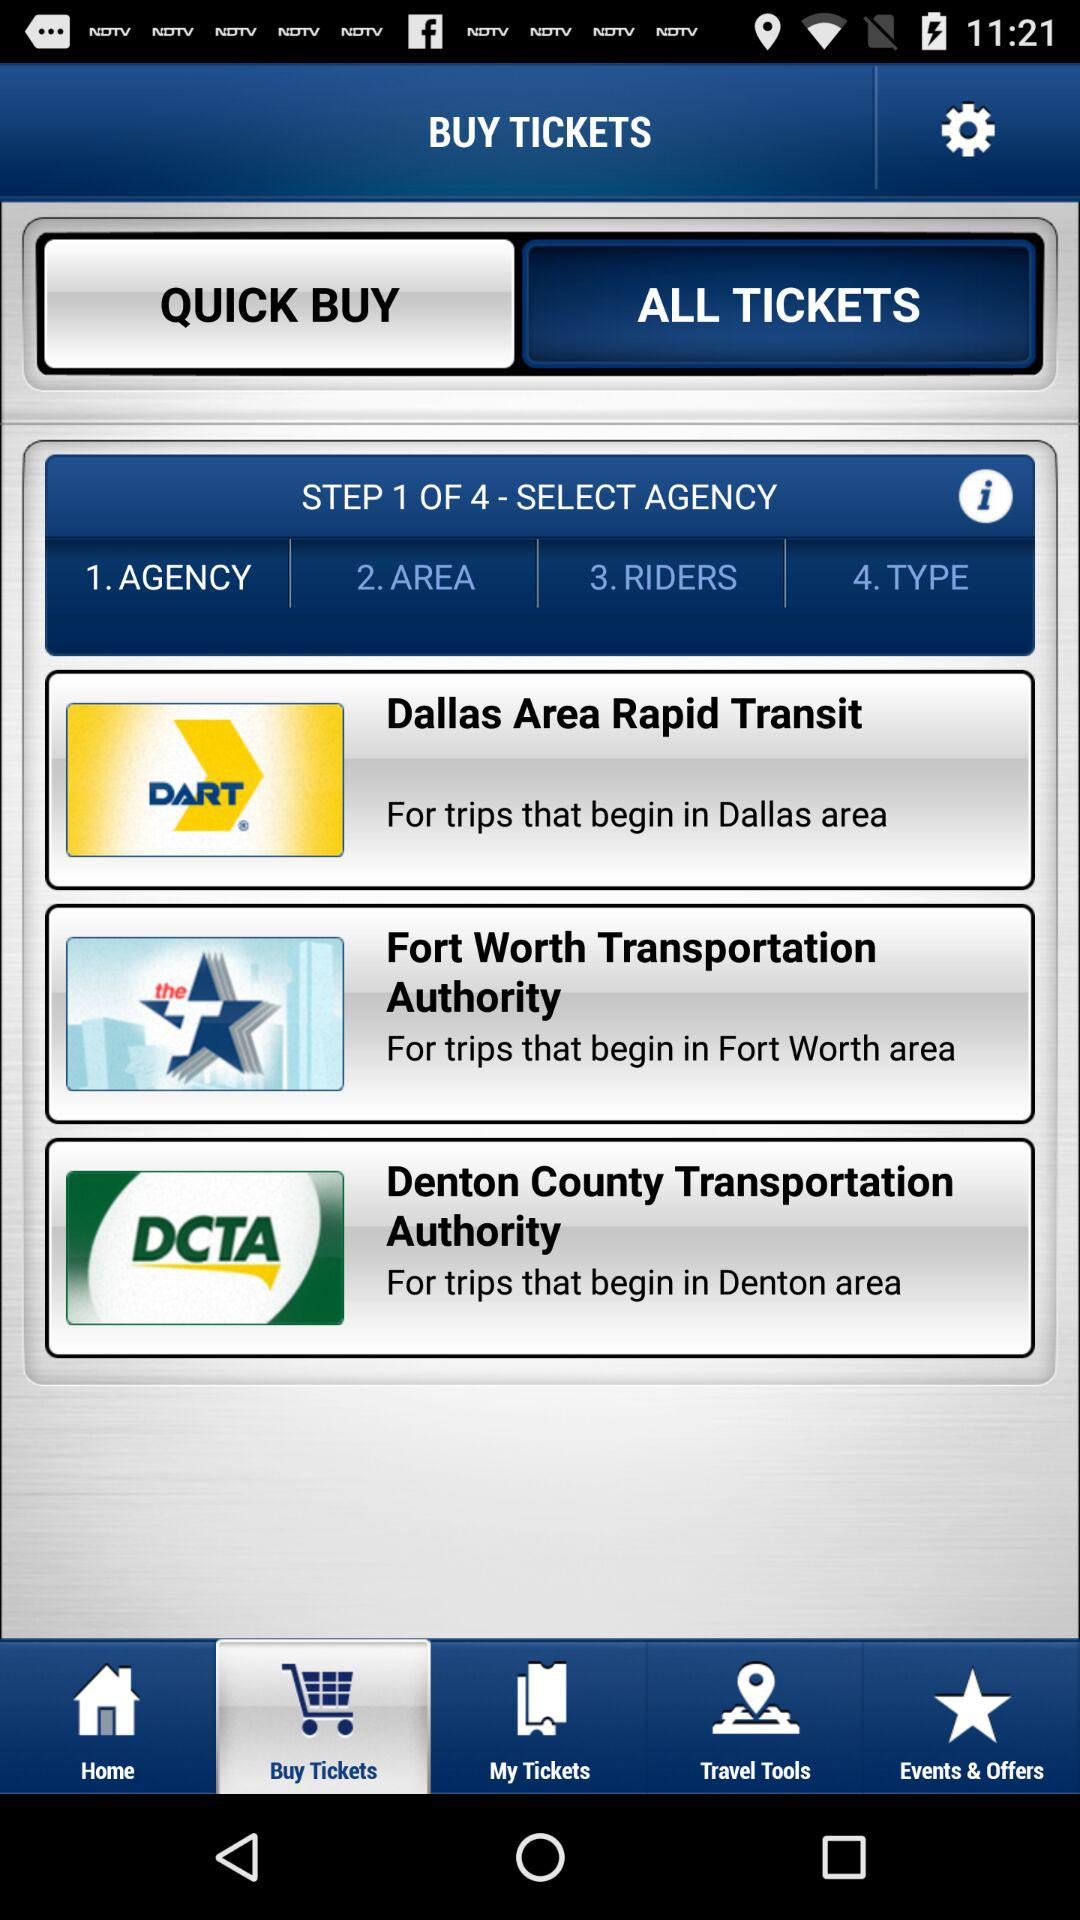How many agencies are available to select from? 3 